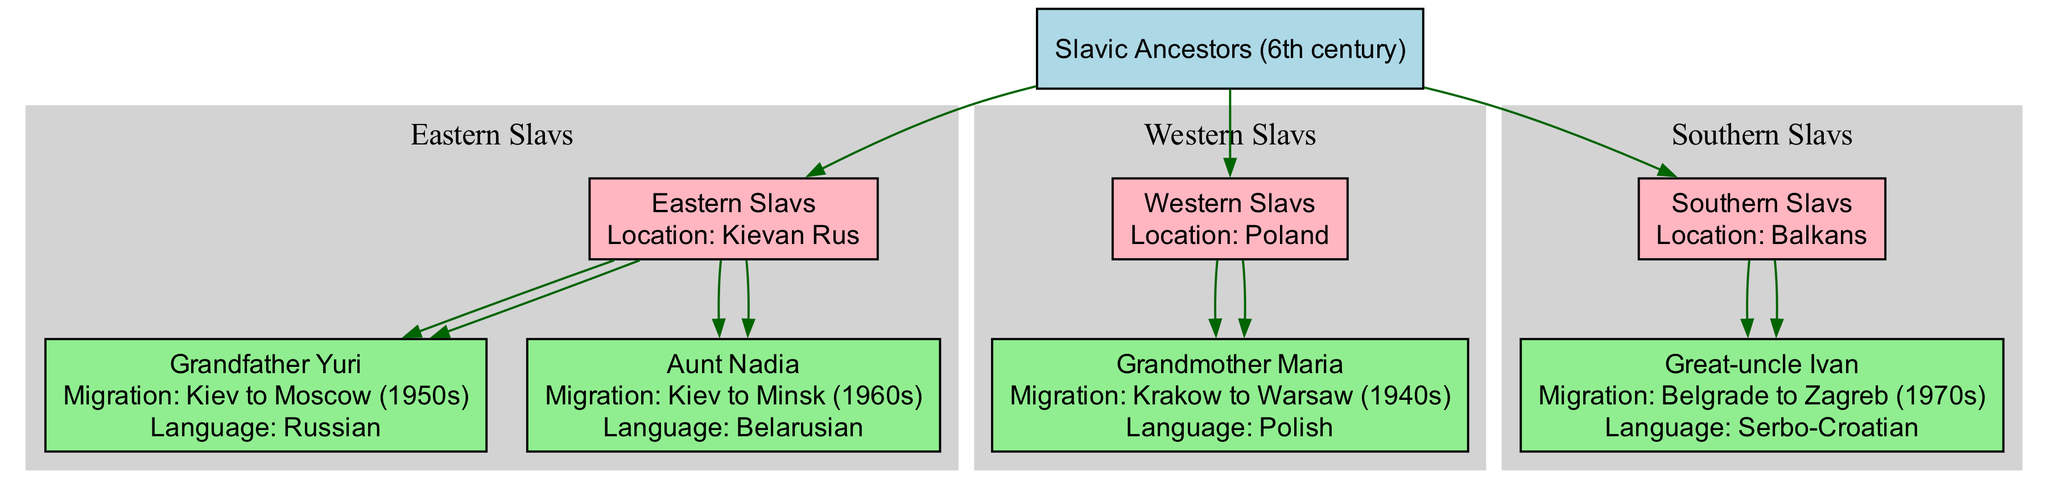What is the root of the family tree? The root node of the diagram is labeled "Slavic Ancestors (6th century)." This is the main origin from which all other branches and nodes stem.
Answer: Slavic Ancestors (6th century) How many main groups of Slavs are depicted in the diagram? The diagram shows three main groups of Slavs: Eastern Slavs, Western Slavs, and Southern Slavs. Each group represents a distinct branch of Slavic ancestry.
Answer: 3 What is the migration path of Grandfather Yuri? Grandfather Yuri is shown to have migrated from Kiev to Moscow in the 1950s. This information is listed under his name in the diagram.
Answer: Kiev to Moscow (1950s) Which language is spoken by Aunt Nadia? Aunt Nadia speaks Belarusian, as indicated in the diagram next to her name. This details her cultural and linguistic background.
Answer: Belarusian Who migrated to Zagreb in the 1970s? The diagram identifies Great-uncle Ivan as the one who migrated from Belgrade to Zagreb during that decade, illustrated in the Southern Slavs group.
Answer: Great-uncle Ivan Which location is associated with Grandmother Maria? Grandmother Maria is associated with the location of Warsaw, having migrated there from Krakow in the 1940s, according to the information provided in the family tree.
Answer: Warsaw What language do the Eastern Slavs predominantly speak? The primary language spoken by Eastern Slavs, as implied by the presence of Yuri and Nadia in the tree, is Russian and Belarusian, reflecting their geographical ties.
Answer: Russian and Belarusian How many children does the Eastern Slavs group have? The Eastern Slavs group has two children (Grandfather Yuri and Aunt Nadia), as listed under that node in the diagram.
Answer: 2 What is the primary location for the Southern Slavs? The primary location associated with the Southern Slavs is the Balkans, as indicated at the root of that branch in the diagram.
Answer: Balkans 